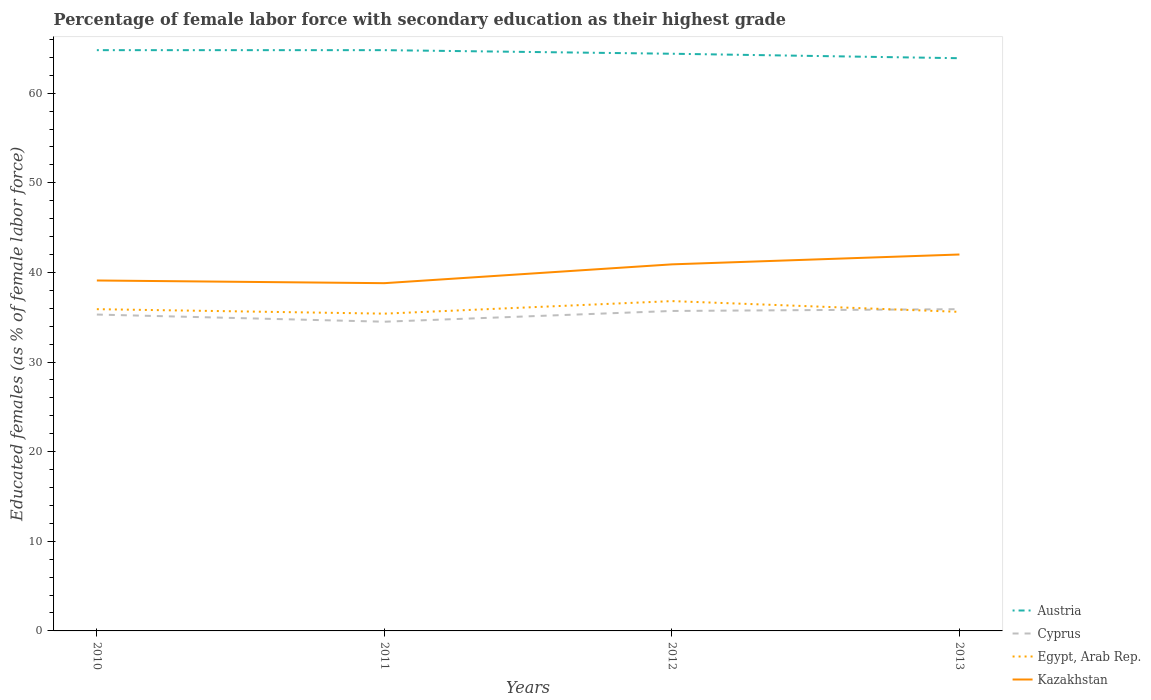How many different coloured lines are there?
Give a very brief answer. 4. Does the line corresponding to Cyprus intersect with the line corresponding to Kazakhstan?
Offer a terse response. No. Across all years, what is the maximum percentage of female labor force with secondary education in Cyprus?
Provide a succinct answer. 34.5. In which year was the percentage of female labor force with secondary education in Cyprus maximum?
Your answer should be very brief. 2011. What is the total percentage of female labor force with secondary education in Austria in the graph?
Your answer should be compact. 0. What is the difference between the highest and the second highest percentage of female labor force with secondary education in Kazakhstan?
Your answer should be compact. 3.2. Is the percentage of female labor force with secondary education in Kazakhstan strictly greater than the percentage of female labor force with secondary education in Austria over the years?
Provide a succinct answer. Yes. What is the difference between two consecutive major ticks on the Y-axis?
Provide a short and direct response. 10. Does the graph contain any zero values?
Offer a very short reply. No. Does the graph contain grids?
Your answer should be very brief. No. Where does the legend appear in the graph?
Make the answer very short. Bottom right. How are the legend labels stacked?
Provide a succinct answer. Vertical. What is the title of the graph?
Keep it short and to the point. Percentage of female labor force with secondary education as their highest grade. What is the label or title of the Y-axis?
Offer a terse response. Educated females (as % of female labor force). What is the Educated females (as % of female labor force) of Austria in 2010?
Give a very brief answer. 64.8. What is the Educated females (as % of female labor force) in Cyprus in 2010?
Give a very brief answer. 35.3. What is the Educated females (as % of female labor force) of Egypt, Arab Rep. in 2010?
Offer a terse response. 35.9. What is the Educated females (as % of female labor force) of Kazakhstan in 2010?
Offer a terse response. 39.1. What is the Educated females (as % of female labor force) in Austria in 2011?
Make the answer very short. 64.8. What is the Educated females (as % of female labor force) of Cyprus in 2011?
Your answer should be very brief. 34.5. What is the Educated females (as % of female labor force) of Egypt, Arab Rep. in 2011?
Offer a terse response. 35.4. What is the Educated females (as % of female labor force) in Kazakhstan in 2011?
Provide a short and direct response. 38.8. What is the Educated females (as % of female labor force) of Austria in 2012?
Keep it short and to the point. 64.4. What is the Educated females (as % of female labor force) in Cyprus in 2012?
Keep it short and to the point. 35.7. What is the Educated females (as % of female labor force) of Egypt, Arab Rep. in 2012?
Keep it short and to the point. 36.8. What is the Educated females (as % of female labor force) in Kazakhstan in 2012?
Offer a very short reply. 40.9. What is the Educated females (as % of female labor force) of Austria in 2013?
Provide a short and direct response. 63.9. What is the Educated females (as % of female labor force) in Cyprus in 2013?
Offer a very short reply. 35.9. What is the Educated females (as % of female labor force) of Egypt, Arab Rep. in 2013?
Make the answer very short. 35.6. Across all years, what is the maximum Educated females (as % of female labor force) of Austria?
Offer a terse response. 64.8. Across all years, what is the maximum Educated females (as % of female labor force) of Cyprus?
Provide a succinct answer. 35.9. Across all years, what is the maximum Educated females (as % of female labor force) of Egypt, Arab Rep.?
Give a very brief answer. 36.8. Across all years, what is the maximum Educated females (as % of female labor force) in Kazakhstan?
Give a very brief answer. 42. Across all years, what is the minimum Educated females (as % of female labor force) of Austria?
Make the answer very short. 63.9. Across all years, what is the minimum Educated females (as % of female labor force) of Cyprus?
Offer a terse response. 34.5. Across all years, what is the minimum Educated females (as % of female labor force) in Egypt, Arab Rep.?
Provide a succinct answer. 35.4. Across all years, what is the minimum Educated females (as % of female labor force) in Kazakhstan?
Your answer should be compact. 38.8. What is the total Educated females (as % of female labor force) of Austria in the graph?
Offer a very short reply. 257.9. What is the total Educated females (as % of female labor force) in Cyprus in the graph?
Your response must be concise. 141.4. What is the total Educated females (as % of female labor force) in Egypt, Arab Rep. in the graph?
Ensure brevity in your answer.  143.7. What is the total Educated females (as % of female labor force) in Kazakhstan in the graph?
Provide a short and direct response. 160.8. What is the difference between the Educated females (as % of female labor force) in Kazakhstan in 2010 and that in 2011?
Ensure brevity in your answer.  0.3. What is the difference between the Educated females (as % of female labor force) in Cyprus in 2010 and that in 2012?
Your answer should be very brief. -0.4. What is the difference between the Educated females (as % of female labor force) of Egypt, Arab Rep. in 2010 and that in 2012?
Your answer should be compact. -0.9. What is the difference between the Educated females (as % of female labor force) of Kazakhstan in 2010 and that in 2012?
Provide a succinct answer. -1.8. What is the difference between the Educated females (as % of female labor force) of Egypt, Arab Rep. in 2010 and that in 2013?
Your response must be concise. 0.3. What is the difference between the Educated females (as % of female labor force) in Kazakhstan in 2010 and that in 2013?
Ensure brevity in your answer.  -2.9. What is the difference between the Educated females (as % of female labor force) of Austria in 2011 and that in 2012?
Offer a terse response. 0.4. What is the difference between the Educated females (as % of female labor force) of Egypt, Arab Rep. in 2011 and that in 2012?
Make the answer very short. -1.4. What is the difference between the Educated females (as % of female labor force) of Kazakhstan in 2011 and that in 2012?
Make the answer very short. -2.1. What is the difference between the Educated females (as % of female labor force) in Austria in 2011 and that in 2013?
Offer a terse response. 0.9. What is the difference between the Educated females (as % of female labor force) of Kazakhstan in 2011 and that in 2013?
Give a very brief answer. -3.2. What is the difference between the Educated females (as % of female labor force) in Austria in 2012 and that in 2013?
Keep it short and to the point. 0.5. What is the difference between the Educated females (as % of female labor force) in Egypt, Arab Rep. in 2012 and that in 2013?
Give a very brief answer. 1.2. What is the difference between the Educated females (as % of female labor force) in Kazakhstan in 2012 and that in 2013?
Ensure brevity in your answer.  -1.1. What is the difference between the Educated females (as % of female labor force) of Austria in 2010 and the Educated females (as % of female labor force) of Cyprus in 2011?
Your response must be concise. 30.3. What is the difference between the Educated females (as % of female labor force) in Austria in 2010 and the Educated females (as % of female labor force) in Egypt, Arab Rep. in 2011?
Your answer should be compact. 29.4. What is the difference between the Educated females (as % of female labor force) in Austria in 2010 and the Educated females (as % of female labor force) in Cyprus in 2012?
Give a very brief answer. 29.1. What is the difference between the Educated females (as % of female labor force) of Austria in 2010 and the Educated females (as % of female labor force) of Kazakhstan in 2012?
Your answer should be compact. 23.9. What is the difference between the Educated females (as % of female labor force) of Cyprus in 2010 and the Educated females (as % of female labor force) of Egypt, Arab Rep. in 2012?
Provide a succinct answer. -1.5. What is the difference between the Educated females (as % of female labor force) in Egypt, Arab Rep. in 2010 and the Educated females (as % of female labor force) in Kazakhstan in 2012?
Keep it short and to the point. -5. What is the difference between the Educated females (as % of female labor force) in Austria in 2010 and the Educated females (as % of female labor force) in Cyprus in 2013?
Keep it short and to the point. 28.9. What is the difference between the Educated females (as % of female labor force) of Austria in 2010 and the Educated females (as % of female labor force) of Egypt, Arab Rep. in 2013?
Provide a short and direct response. 29.2. What is the difference between the Educated females (as % of female labor force) of Austria in 2010 and the Educated females (as % of female labor force) of Kazakhstan in 2013?
Your answer should be very brief. 22.8. What is the difference between the Educated females (as % of female labor force) of Austria in 2011 and the Educated females (as % of female labor force) of Cyprus in 2012?
Your answer should be very brief. 29.1. What is the difference between the Educated females (as % of female labor force) in Austria in 2011 and the Educated females (as % of female labor force) in Kazakhstan in 2012?
Provide a short and direct response. 23.9. What is the difference between the Educated females (as % of female labor force) of Cyprus in 2011 and the Educated females (as % of female labor force) of Egypt, Arab Rep. in 2012?
Offer a terse response. -2.3. What is the difference between the Educated females (as % of female labor force) of Egypt, Arab Rep. in 2011 and the Educated females (as % of female labor force) of Kazakhstan in 2012?
Your answer should be very brief. -5.5. What is the difference between the Educated females (as % of female labor force) of Austria in 2011 and the Educated females (as % of female labor force) of Cyprus in 2013?
Offer a very short reply. 28.9. What is the difference between the Educated females (as % of female labor force) in Austria in 2011 and the Educated females (as % of female labor force) in Egypt, Arab Rep. in 2013?
Make the answer very short. 29.2. What is the difference between the Educated females (as % of female labor force) of Austria in 2011 and the Educated females (as % of female labor force) of Kazakhstan in 2013?
Give a very brief answer. 22.8. What is the difference between the Educated females (as % of female labor force) in Cyprus in 2011 and the Educated females (as % of female labor force) in Egypt, Arab Rep. in 2013?
Provide a succinct answer. -1.1. What is the difference between the Educated females (as % of female labor force) in Cyprus in 2011 and the Educated females (as % of female labor force) in Kazakhstan in 2013?
Ensure brevity in your answer.  -7.5. What is the difference between the Educated females (as % of female labor force) of Egypt, Arab Rep. in 2011 and the Educated females (as % of female labor force) of Kazakhstan in 2013?
Your response must be concise. -6.6. What is the difference between the Educated females (as % of female labor force) in Austria in 2012 and the Educated females (as % of female labor force) in Cyprus in 2013?
Your answer should be compact. 28.5. What is the difference between the Educated females (as % of female labor force) in Austria in 2012 and the Educated females (as % of female labor force) in Egypt, Arab Rep. in 2013?
Your answer should be compact. 28.8. What is the difference between the Educated females (as % of female labor force) of Austria in 2012 and the Educated females (as % of female labor force) of Kazakhstan in 2013?
Give a very brief answer. 22.4. What is the difference between the Educated females (as % of female labor force) in Cyprus in 2012 and the Educated females (as % of female labor force) in Egypt, Arab Rep. in 2013?
Your answer should be very brief. 0.1. What is the difference between the Educated females (as % of female labor force) of Egypt, Arab Rep. in 2012 and the Educated females (as % of female labor force) of Kazakhstan in 2013?
Provide a succinct answer. -5.2. What is the average Educated females (as % of female labor force) in Austria per year?
Ensure brevity in your answer.  64.47. What is the average Educated females (as % of female labor force) in Cyprus per year?
Your answer should be compact. 35.35. What is the average Educated females (as % of female labor force) in Egypt, Arab Rep. per year?
Give a very brief answer. 35.92. What is the average Educated females (as % of female labor force) in Kazakhstan per year?
Your answer should be compact. 40.2. In the year 2010, what is the difference between the Educated females (as % of female labor force) of Austria and Educated females (as % of female labor force) of Cyprus?
Make the answer very short. 29.5. In the year 2010, what is the difference between the Educated females (as % of female labor force) in Austria and Educated females (as % of female labor force) in Egypt, Arab Rep.?
Give a very brief answer. 28.9. In the year 2010, what is the difference between the Educated females (as % of female labor force) in Austria and Educated females (as % of female labor force) in Kazakhstan?
Give a very brief answer. 25.7. In the year 2010, what is the difference between the Educated females (as % of female labor force) in Egypt, Arab Rep. and Educated females (as % of female labor force) in Kazakhstan?
Keep it short and to the point. -3.2. In the year 2011, what is the difference between the Educated females (as % of female labor force) in Austria and Educated females (as % of female labor force) in Cyprus?
Your answer should be very brief. 30.3. In the year 2011, what is the difference between the Educated females (as % of female labor force) in Austria and Educated females (as % of female labor force) in Egypt, Arab Rep.?
Keep it short and to the point. 29.4. In the year 2011, what is the difference between the Educated females (as % of female labor force) of Austria and Educated females (as % of female labor force) of Kazakhstan?
Make the answer very short. 26. In the year 2012, what is the difference between the Educated females (as % of female labor force) in Austria and Educated females (as % of female labor force) in Cyprus?
Your response must be concise. 28.7. In the year 2012, what is the difference between the Educated females (as % of female labor force) of Austria and Educated females (as % of female labor force) of Egypt, Arab Rep.?
Make the answer very short. 27.6. In the year 2012, what is the difference between the Educated females (as % of female labor force) in Austria and Educated females (as % of female labor force) in Kazakhstan?
Offer a terse response. 23.5. In the year 2012, what is the difference between the Educated females (as % of female labor force) in Cyprus and Educated females (as % of female labor force) in Kazakhstan?
Make the answer very short. -5.2. In the year 2012, what is the difference between the Educated females (as % of female labor force) of Egypt, Arab Rep. and Educated females (as % of female labor force) of Kazakhstan?
Keep it short and to the point. -4.1. In the year 2013, what is the difference between the Educated females (as % of female labor force) in Austria and Educated females (as % of female labor force) in Cyprus?
Offer a very short reply. 28. In the year 2013, what is the difference between the Educated females (as % of female labor force) in Austria and Educated females (as % of female labor force) in Egypt, Arab Rep.?
Your answer should be compact. 28.3. In the year 2013, what is the difference between the Educated females (as % of female labor force) in Austria and Educated females (as % of female labor force) in Kazakhstan?
Ensure brevity in your answer.  21.9. What is the ratio of the Educated females (as % of female labor force) of Austria in 2010 to that in 2011?
Provide a succinct answer. 1. What is the ratio of the Educated females (as % of female labor force) in Cyprus in 2010 to that in 2011?
Keep it short and to the point. 1.02. What is the ratio of the Educated females (as % of female labor force) in Egypt, Arab Rep. in 2010 to that in 2011?
Provide a short and direct response. 1.01. What is the ratio of the Educated females (as % of female labor force) in Kazakhstan in 2010 to that in 2011?
Your response must be concise. 1.01. What is the ratio of the Educated females (as % of female labor force) of Austria in 2010 to that in 2012?
Give a very brief answer. 1.01. What is the ratio of the Educated females (as % of female labor force) of Cyprus in 2010 to that in 2012?
Offer a very short reply. 0.99. What is the ratio of the Educated females (as % of female labor force) in Egypt, Arab Rep. in 2010 to that in 2012?
Provide a succinct answer. 0.98. What is the ratio of the Educated females (as % of female labor force) of Kazakhstan in 2010 to that in 2012?
Provide a succinct answer. 0.96. What is the ratio of the Educated females (as % of female labor force) in Austria in 2010 to that in 2013?
Your response must be concise. 1.01. What is the ratio of the Educated females (as % of female labor force) in Cyprus in 2010 to that in 2013?
Provide a succinct answer. 0.98. What is the ratio of the Educated females (as % of female labor force) of Egypt, Arab Rep. in 2010 to that in 2013?
Provide a succinct answer. 1.01. What is the ratio of the Educated females (as % of female labor force) of Kazakhstan in 2010 to that in 2013?
Give a very brief answer. 0.93. What is the ratio of the Educated females (as % of female labor force) in Cyprus in 2011 to that in 2012?
Make the answer very short. 0.97. What is the ratio of the Educated females (as % of female labor force) of Kazakhstan in 2011 to that in 2012?
Your answer should be compact. 0.95. What is the ratio of the Educated females (as % of female labor force) in Austria in 2011 to that in 2013?
Offer a terse response. 1.01. What is the ratio of the Educated females (as % of female labor force) of Egypt, Arab Rep. in 2011 to that in 2013?
Give a very brief answer. 0.99. What is the ratio of the Educated females (as % of female labor force) of Kazakhstan in 2011 to that in 2013?
Your answer should be compact. 0.92. What is the ratio of the Educated females (as % of female labor force) of Egypt, Arab Rep. in 2012 to that in 2013?
Provide a short and direct response. 1.03. What is the ratio of the Educated females (as % of female labor force) in Kazakhstan in 2012 to that in 2013?
Your response must be concise. 0.97. What is the difference between the highest and the second highest Educated females (as % of female labor force) of Austria?
Offer a terse response. 0. What is the difference between the highest and the second highest Educated females (as % of female labor force) in Cyprus?
Offer a terse response. 0.2. What is the difference between the highest and the second highest Educated females (as % of female labor force) of Kazakhstan?
Give a very brief answer. 1.1. What is the difference between the highest and the lowest Educated females (as % of female labor force) of Cyprus?
Give a very brief answer. 1.4. What is the difference between the highest and the lowest Educated females (as % of female labor force) of Kazakhstan?
Your answer should be very brief. 3.2. 